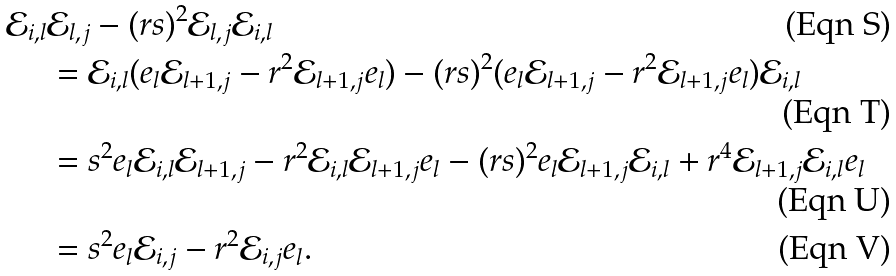<formula> <loc_0><loc_0><loc_500><loc_500>\mathcal { E } _ { i , l } & \mathcal { E } _ { l , j } - ( r s ) ^ { 2 } \mathcal { E } _ { l , j } \mathcal { E } _ { i , l } \\ & = \mathcal { E } _ { i , l } ( e _ { l } \mathcal { E } _ { l + 1 , j } - r ^ { 2 } \mathcal { E } _ { l + 1 , j } e _ { l } ) - ( r s ) ^ { 2 } ( e _ { l } \mathcal { E } _ { l + 1 , j } - r ^ { 2 } \mathcal { E } _ { l + 1 , j } e _ { l } ) \mathcal { E } _ { i , l } \\ & = s ^ { 2 } e _ { l } \mathcal { E } _ { i , l } \mathcal { E } _ { l + 1 , j } - r ^ { 2 } \mathcal { E } _ { i , l } \mathcal { E } _ { l + 1 , j } e _ { l } - ( r s ) ^ { 2 } e _ { l } \mathcal { E } _ { l + 1 , j } \mathcal { E } _ { i , l } + r ^ { 4 } \mathcal { E } _ { l + 1 , j } \mathcal { E } _ { i , l } e _ { l } \\ & = s ^ { 2 } e _ { l } \mathcal { E } _ { i , j } - r ^ { 2 } \mathcal { E } _ { i , j } e _ { l } .</formula> 